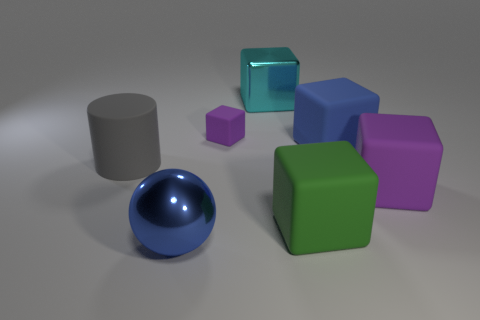How many other things are there of the same material as the big purple object?
Provide a short and direct response. 4. What number of things are either big rubber objects that are to the right of the large metal ball or metal balls?
Your answer should be very brief. 4. There is a purple thing on the right side of the blue thing that is behind the blue metal thing; what shape is it?
Make the answer very short. Cube. There is a blue object right of the cyan metallic cube; is it the same shape as the big cyan object?
Keep it short and to the point. Yes. There is a metal object that is behind the small purple matte block; what is its color?
Ensure brevity in your answer.  Cyan. What number of cubes are matte things or blue things?
Provide a short and direct response. 4. What size is the purple rubber object to the right of the large shiny object that is behind the tiny rubber block?
Ensure brevity in your answer.  Large. Is the color of the big shiny ball the same as the big rubber object behind the large gray thing?
Your answer should be very brief. Yes. There is a cyan block; what number of big blue rubber things are in front of it?
Provide a succinct answer. 1. Are there fewer big gray balls than big green matte cubes?
Provide a succinct answer. Yes. 